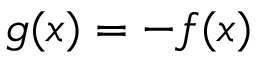<formula> <loc_0><loc_0><loc_500><loc_500>g ( x ) = - f ( x )</formula> 